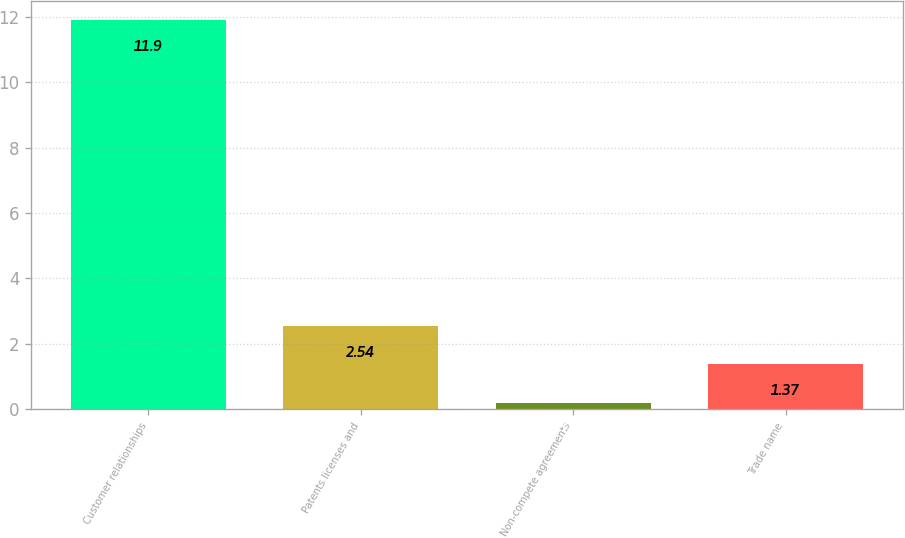Convert chart to OTSL. <chart><loc_0><loc_0><loc_500><loc_500><bar_chart><fcel>Customer relationships<fcel>Patents licenses and<fcel>Non-compete agreements<fcel>Trade name<nl><fcel>11.9<fcel>2.54<fcel>0.2<fcel>1.37<nl></chart> 